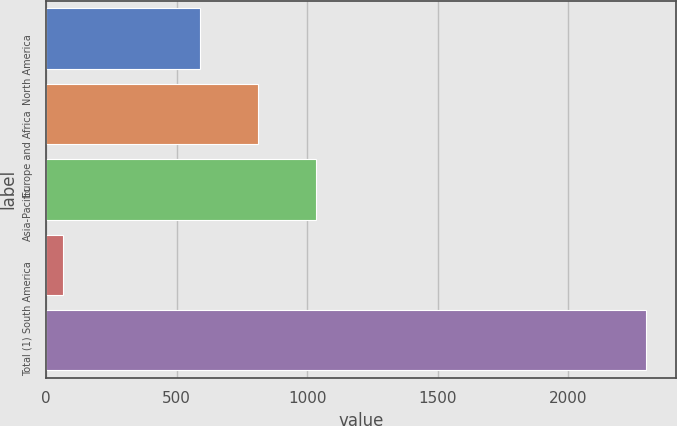Convert chart. <chart><loc_0><loc_0><loc_500><loc_500><bar_chart><fcel>North America<fcel>Europe and Africa<fcel>Asia-Pacific<fcel>South America<fcel>Total (1)<nl><fcel>588<fcel>811.1<fcel>1034.2<fcel>66<fcel>2297<nl></chart> 